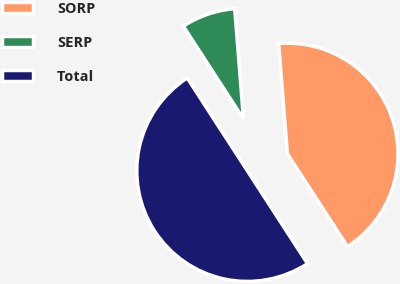Convert chart to OTSL. <chart><loc_0><loc_0><loc_500><loc_500><pie_chart><fcel>SORP<fcel>SERP<fcel>Total<nl><fcel>42.11%<fcel>7.89%<fcel>50.0%<nl></chart> 